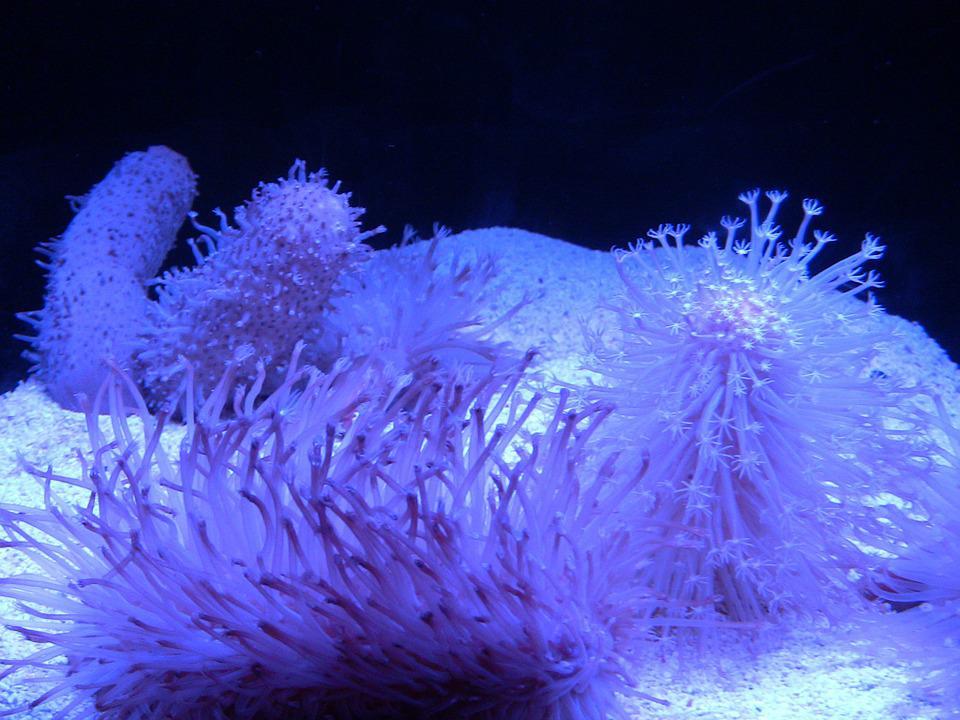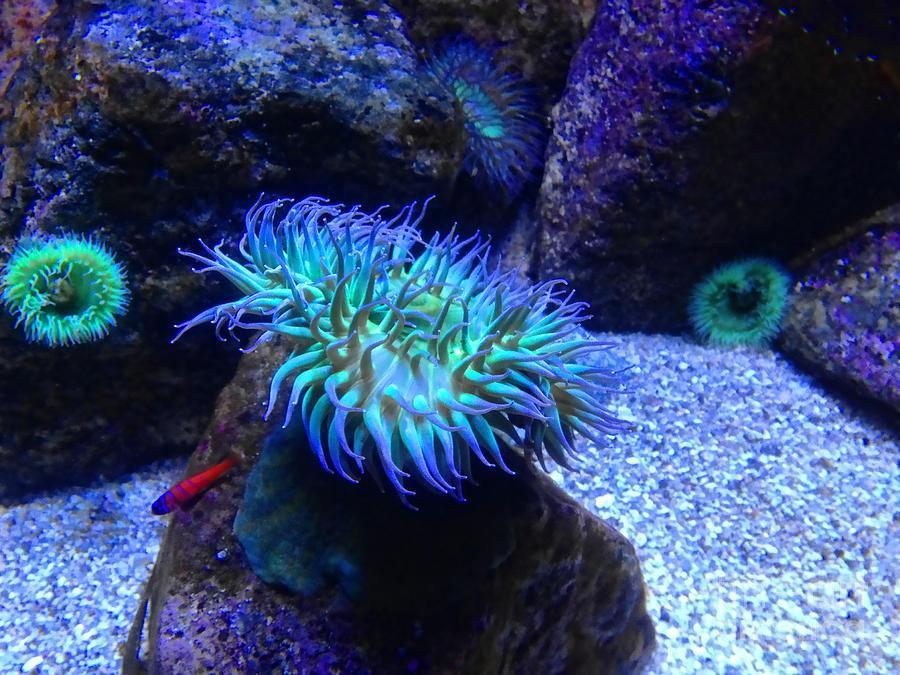The first image is the image on the left, the second image is the image on the right. For the images shown, is this caption "At least one sea anemone is pedominantly pink." true? Answer yes or no. No. The first image is the image on the left, the second image is the image on the right. Assess this claim about the two images: "One image includes at least one distinctive flower-shaped anemone that stands out from its background, and the other shows a nearly monochromatic scene.". Correct or not? Answer yes or no. Yes. 